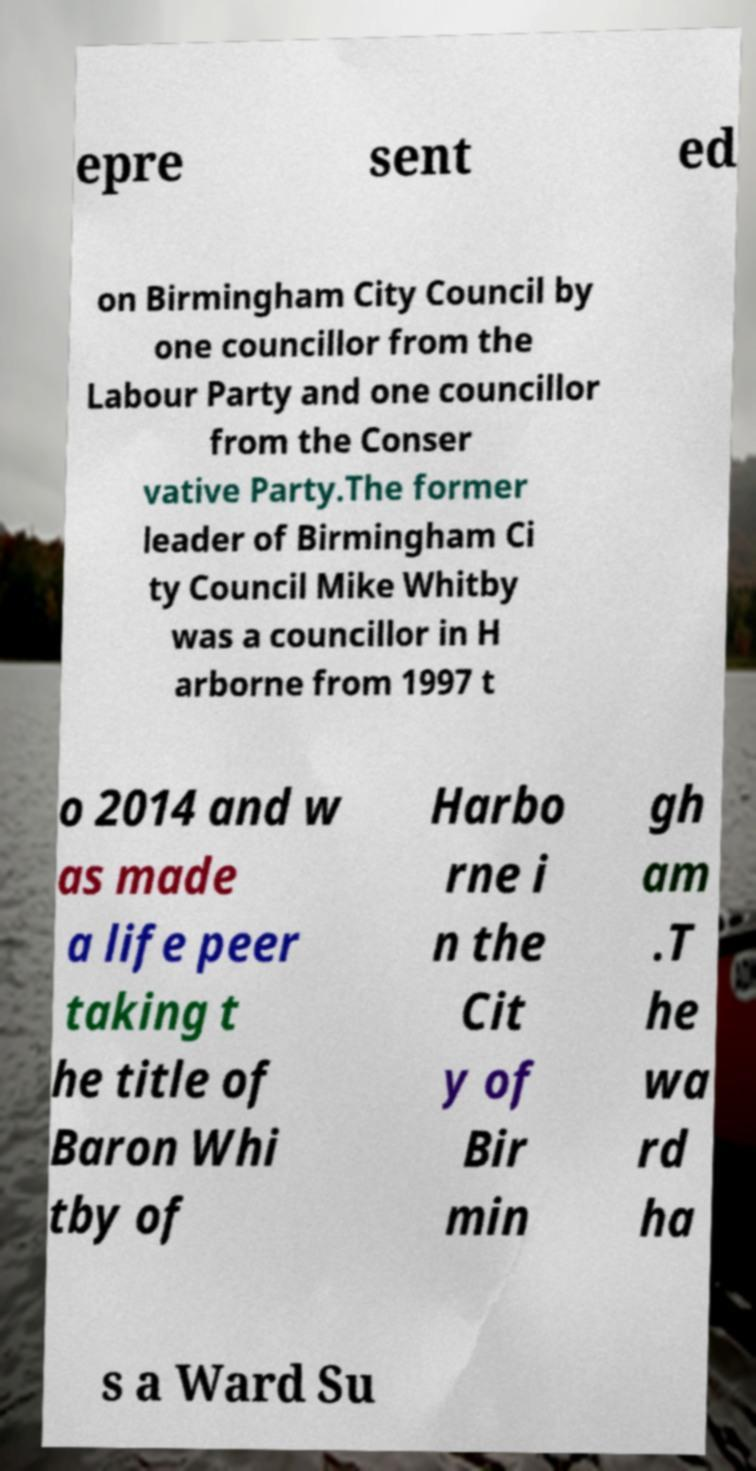What messages or text are displayed in this image? I need them in a readable, typed format. epre sent ed on Birmingham City Council by one councillor from the Labour Party and one councillor from the Conser vative Party.The former leader of Birmingham Ci ty Council Mike Whitby was a councillor in H arborne from 1997 t o 2014 and w as made a life peer taking t he title of Baron Whi tby of Harbo rne i n the Cit y of Bir min gh am .T he wa rd ha s a Ward Su 